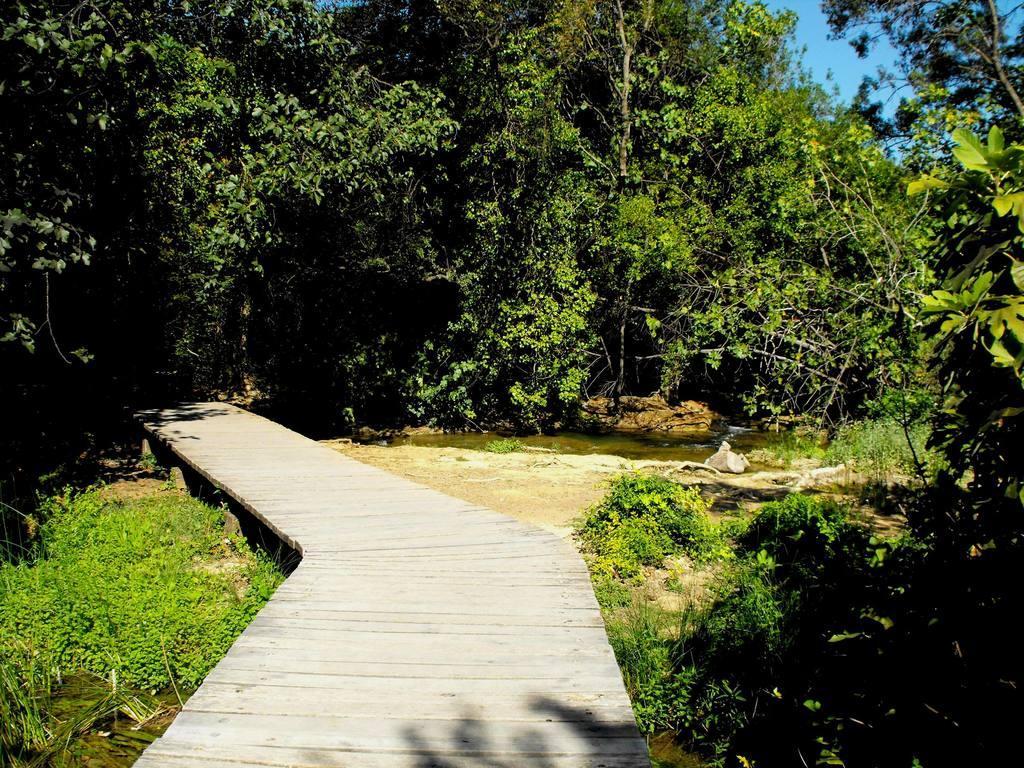In one or two sentences, can you explain what this image depicts? In the picture we can see a wooden path on the plants and water and in the background, we can see, full of plants and part of the sky at the top of it. 